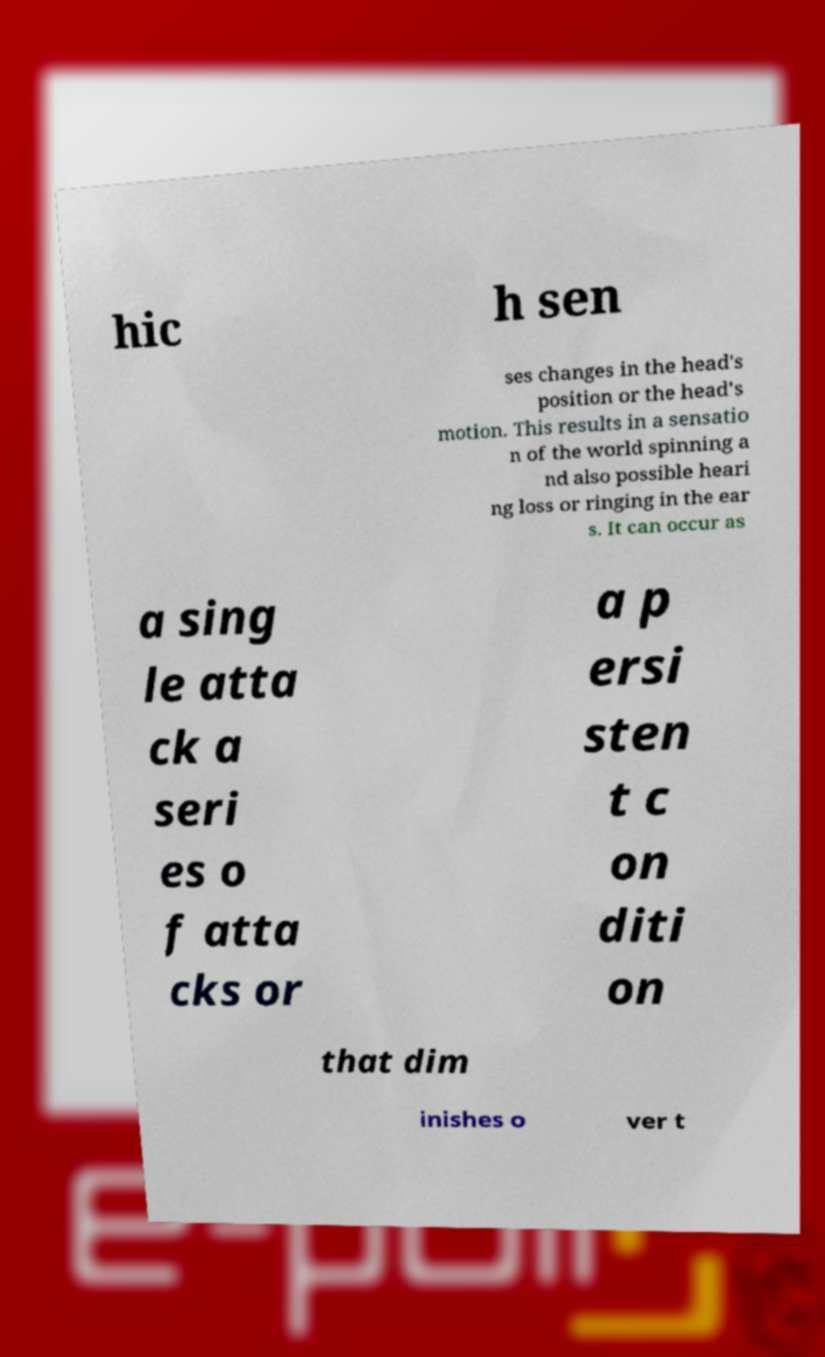There's text embedded in this image that I need extracted. Can you transcribe it verbatim? hic h sen ses changes in the head's position or the head's motion. This results in a sensatio n of the world spinning a nd also possible heari ng loss or ringing in the ear s. It can occur as a sing le atta ck a seri es o f atta cks or a p ersi sten t c on diti on that dim inishes o ver t 